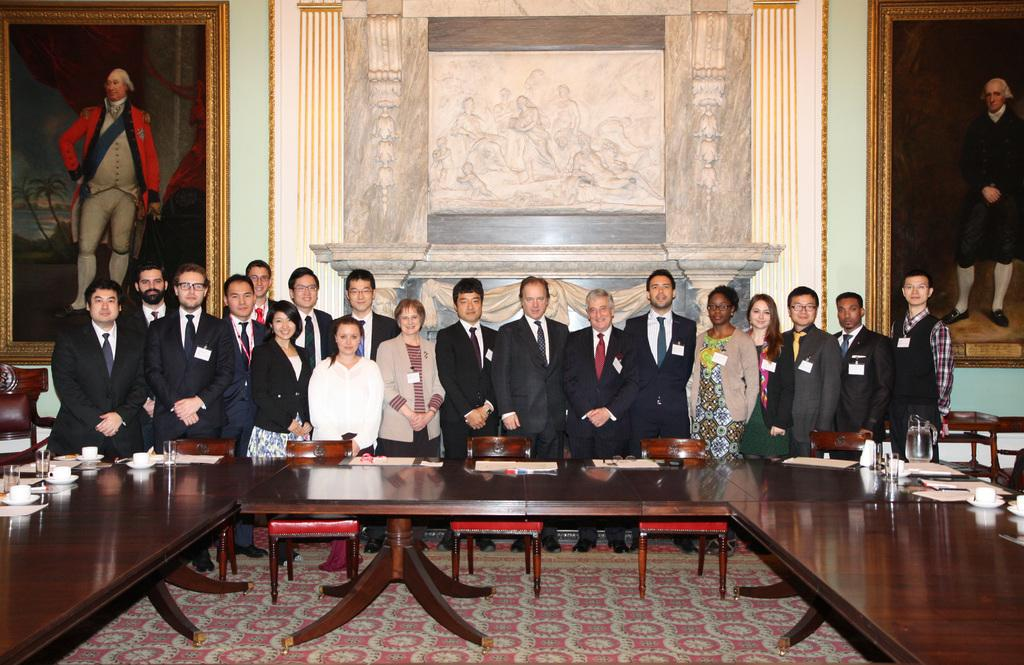How many people are in the image? There is a group of persons in the image, but the exact number is not specified. What are the persons in the image doing? The persons are standing together in the image. What can be seen in the background of the image? There are big photographs in the image, and there is also a wall. What type of voyage are the persons embarking on in the image? There is no indication of a voyage in the image; the persons are simply standing together. What idea is being expressed by the big photographs in the image? The big photographs in the image do not express any specific idea; they are just part of the background. 